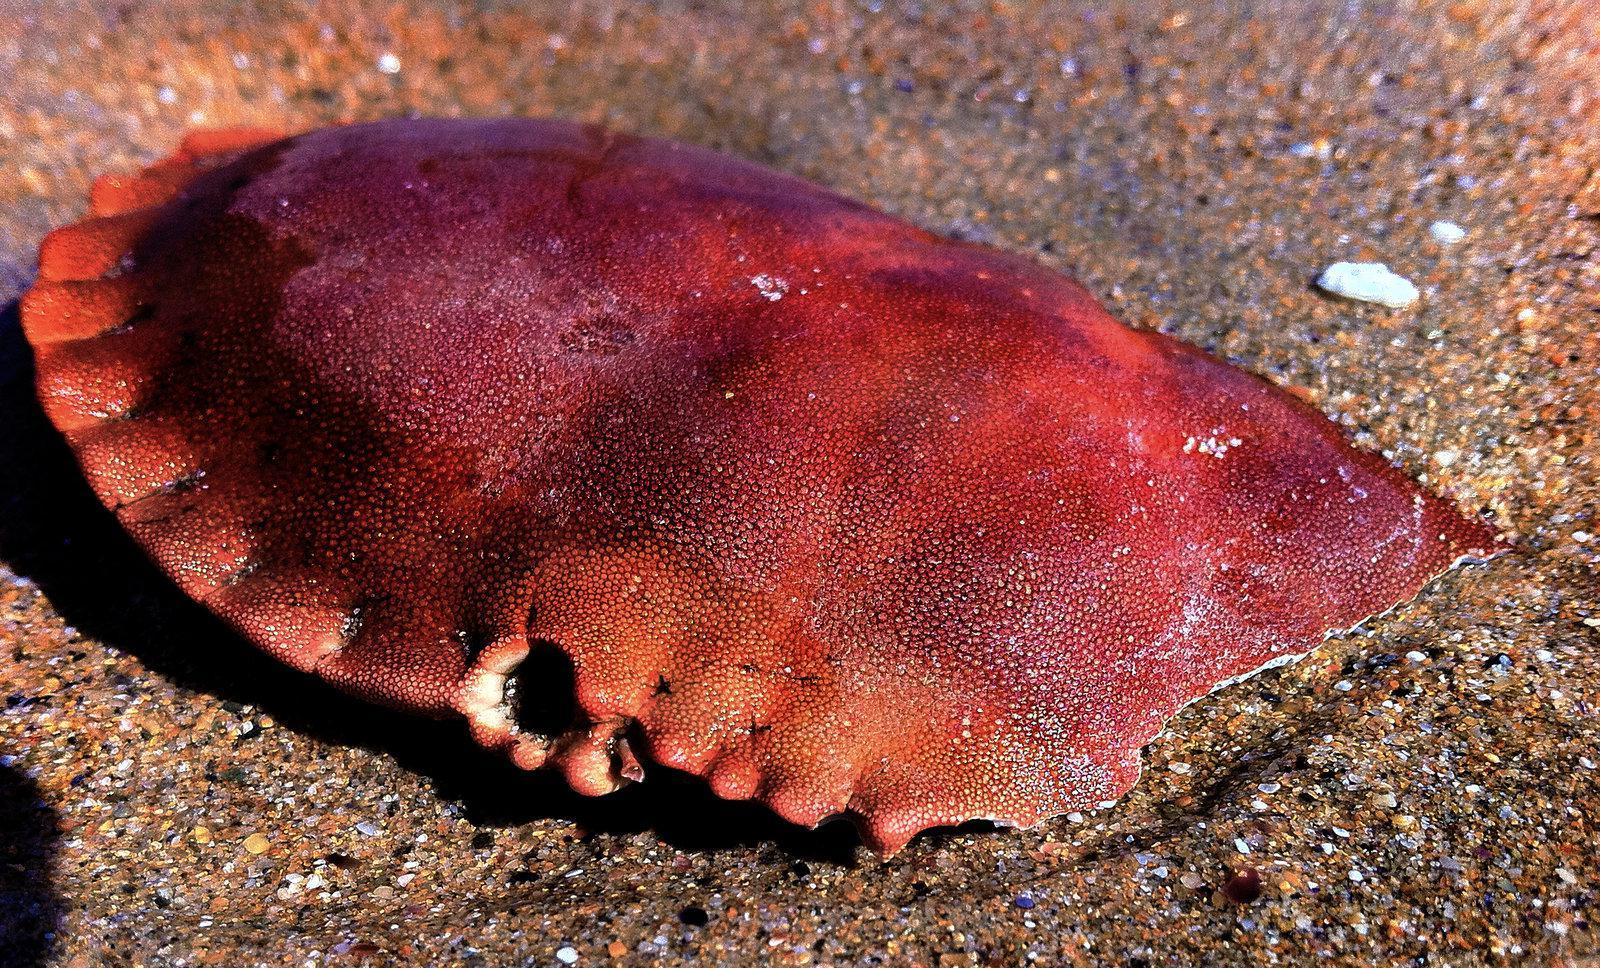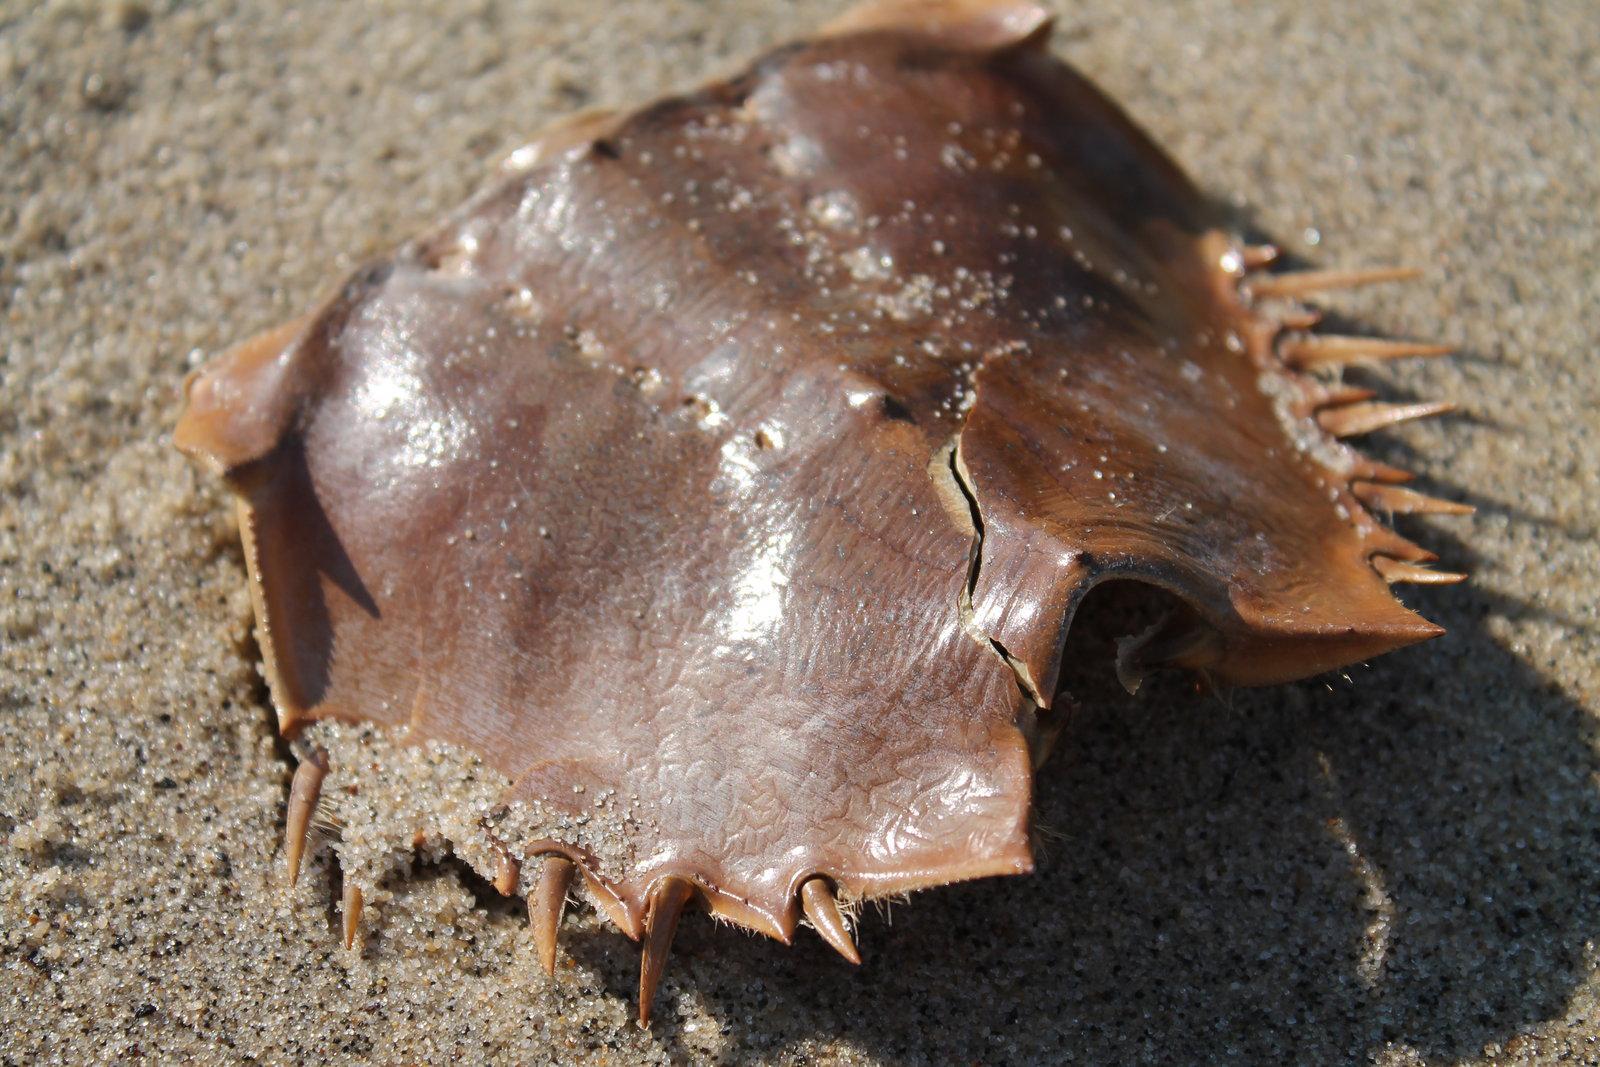The first image is the image on the left, the second image is the image on the right. Considering the images on both sides, is "there are two crab sheels on the sand in the image pair" valid? Answer yes or no. Yes. The first image is the image on the left, the second image is the image on the right. Given the left and right images, does the statement "Each crab sits on a sandy surface." hold true? Answer yes or no. Yes. 